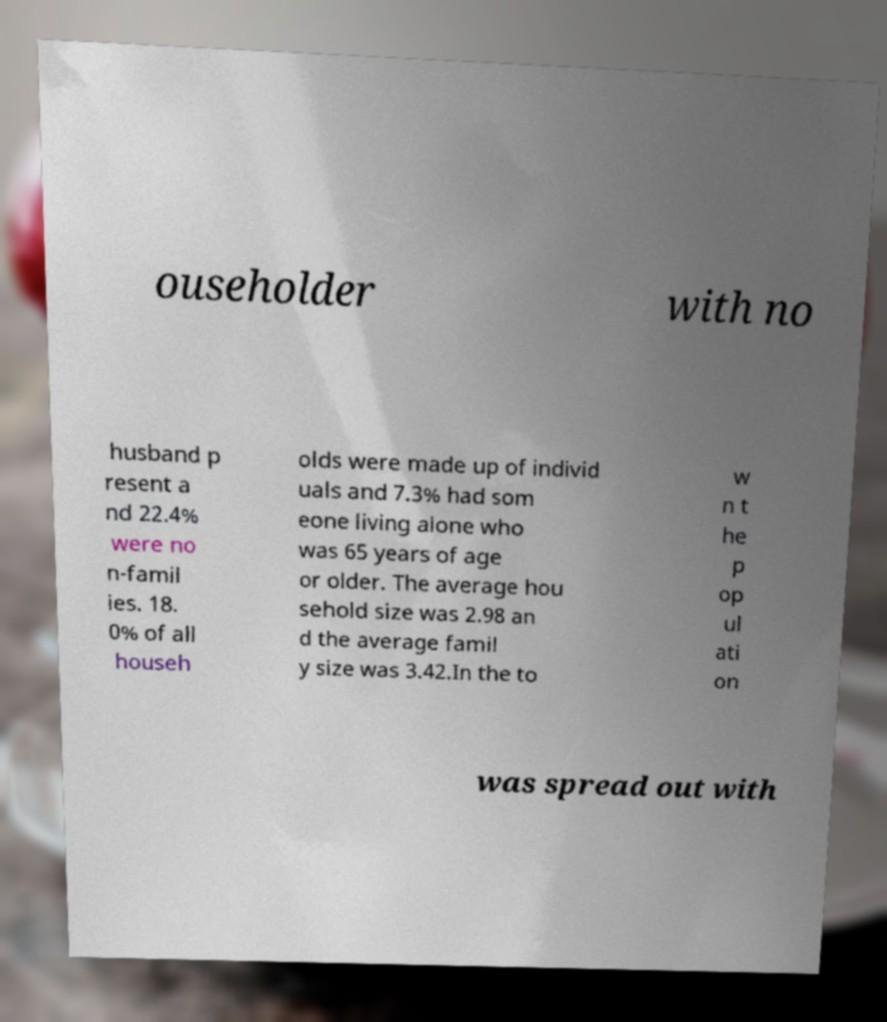I need the written content from this picture converted into text. Can you do that? ouseholder with no husband p resent a nd 22.4% were no n-famil ies. 18. 0% of all househ olds were made up of individ uals and 7.3% had som eone living alone who was 65 years of age or older. The average hou sehold size was 2.98 an d the average famil y size was 3.42.In the to w n t he p op ul ati on was spread out with 